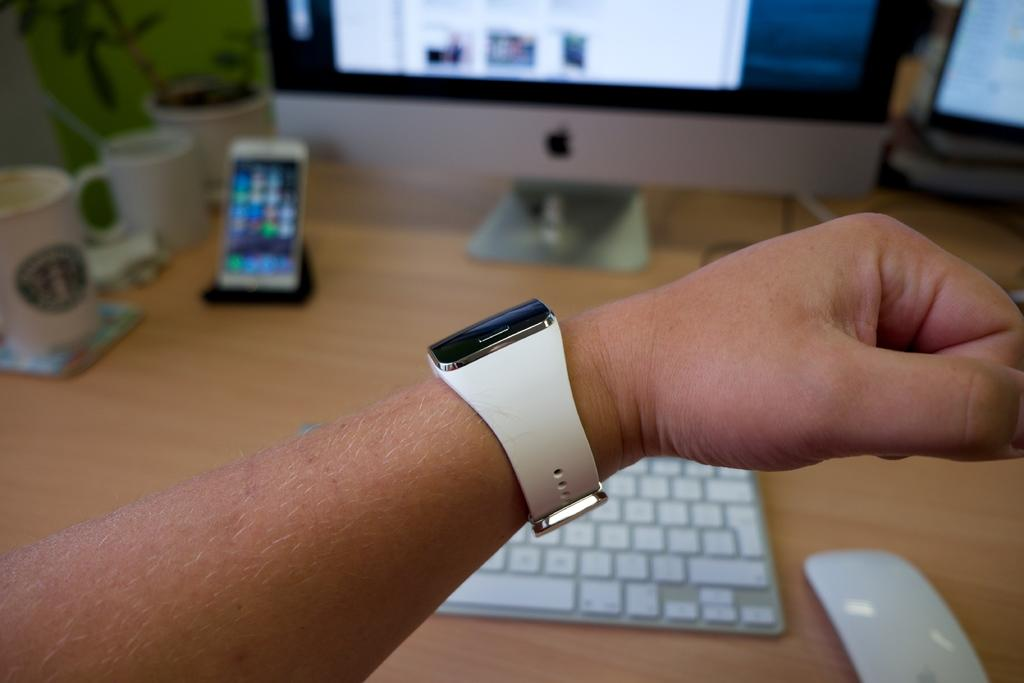What part of a person can be seen in the image? There is a man's hand in the image. What accessory is the man wearing on his hand? The man is wearing a watch. What electronic devices are visible in the background of the image? There is a mobile and a television in the background of the image. What type of hammer is being used to fix the ground in the image? There is no hammer or ground present in the image. What type of school can be seen in the background of the image? There is no school present in the image; it only features a man's hand, a watch, a mobile, and a television. 